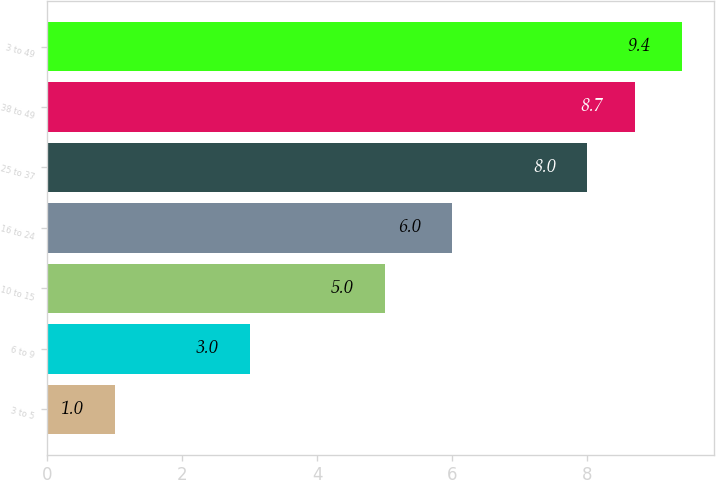Convert chart. <chart><loc_0><loc_0><loc_500><loc_500><bar_chart><fcel>3 to 5<fcel>6 to 9<fcel>10 to 15<fcel>16 to 24<fcel>25 to 37<fcel>38 to 49<fcel>3 to 49<nl><fcel>1<fcel>3<fcel>5<fcel>6<fcel>8<fcel>8.7<fcel>9.4<nl></chart> 